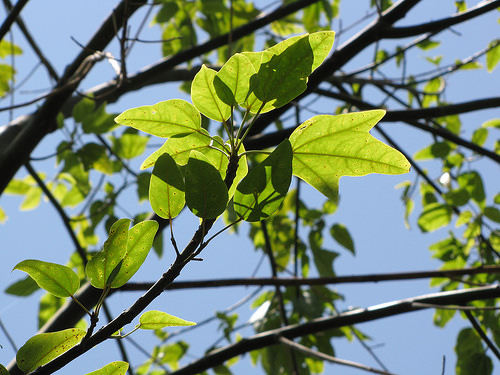<image>
Is there a leaf above the sky? No. The leaf is not positioned above the sky. The vertical arrangement shows a different relationship. 